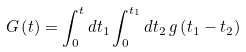<formula> <loc_0><loc_0><loc_500><loc_500>G \left ( t \right ) & = \int _ { 0 } ^ { t } d t _ { 1 } \int _ { 0 } ^ { t _ { 1 } } d t _ { 2 } \, g \left ( t _ { 1 } - t _ { 2 } \right )</formula> 